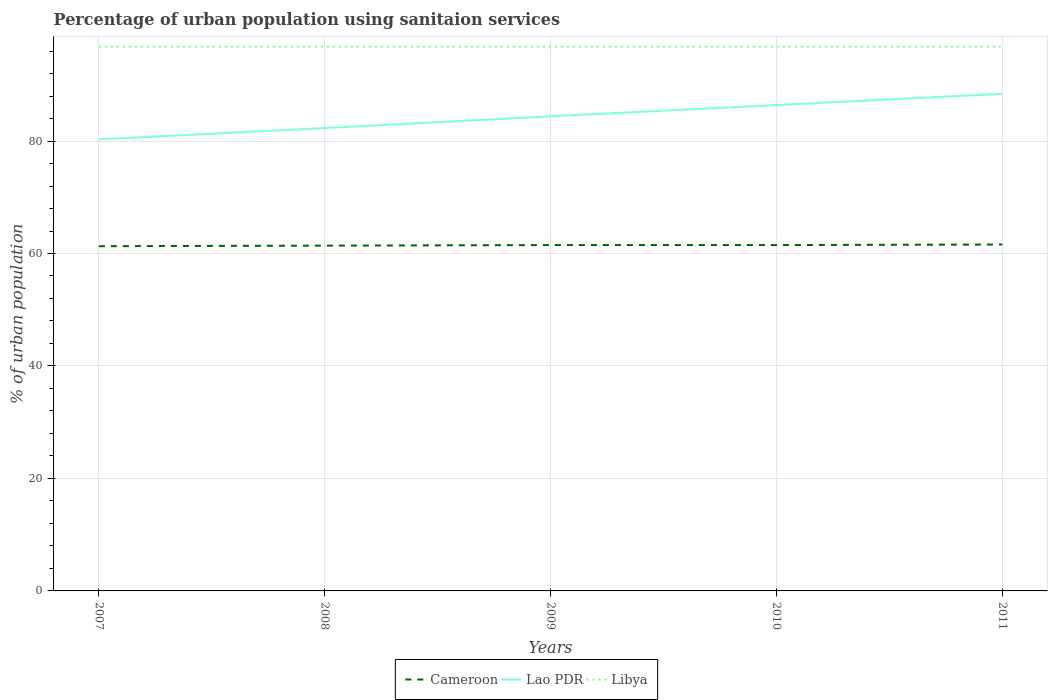Is the number of lines equal to the number of legend labels?
Your response must be concise. Yes. Across all years, what is the maximum percentage of urban population using sanitaion services in Lao PDR?
Your response must be concise. 80.3. In which year was the percentage of urban population using sanitaion services in Lao PDR maximum?
Give a very brief answer. 2007. What is the total percentage of urban population using sanitaion services in Libya in the graph?
Provide a succinct answer. 0. What is the difference between the highest and the second highest percentage of urban population using sanitaion services in Lao PDR?
Your answer should be compact. 8.1. What is the difference between the highest and the lowest percentage of urban population using sanitaion services in Cameroon?
Your response must be concise. 3. Where does the legend appear in the graph?
Provide a short and direct response. Bottom center. What is the title of the graph?
Your response must be concise. Percentage of urban population using sanitaion services. What is the label or title of the X-axis?
Provide a short and direct response. Years. What is the label or title of the Y-axis?
Your response must be concise. % of urban population. What is the % of urban population of Cameroon in 2007?
Offer a terse response. 61.3. What is the % of urban population of Lao PDR in 2007?
Keep it short and to the point. 80.3. What is the % of urban population in Libya in 2007?
Provide a short and direct response. 96.8. What is the % of urban population in Cameroon in 2008?
Give a very brief answer. 61.4. What is the % of urban population in Lao PDR in 2008?
Give a very brief answer. 82.3. What is the % of urban population in Libya in 2008?
Ensure brevity in your answer.  96.8. What is the % of urban population in Cameroon in 2009?
Offer a terse response. 61.5. What is the % of urban population in Lao PDR in 2009?
Provide a short and direct response. 84.4. What is the % of urban population in Libya in 2009?
Your answer should be compact. 96.8. What is the % of urban population in Cameroon in 2010?
Your answer should be very brief. 61.5. What is the % of urban population in Lao PDR in 2010?
Your answer should be very brief. 86.4. What is the % of urban population in Libya in 2010?
Ensure brevity in your answer.  96.8. What is the % of urban population of Cameroon in 2011?
Offer a terse response. 61.6. What is the % of urban population of Lao PDR in 2011?
Your answer should be compact. 88.4. What is the % of urban population in Libya in 2011?
Your answer should be compact. 96.8. Across all years, what is the maximum % of urban population of Cameroon?
Keep it short and to the point. 61.6. Across all years, what is the maximum % of urban population in Lao PDR?
Ensure brevity in your answer.  88.4. Across all years, what is the maximum % of urban population of Libya?
Keep it short and to the point. 96.8. Across all years, what is the minimum % of urban population in Cameroon?
Offer a terse response. 61.3. Across all years, what is the minimum % of urban population in Lao PDR?
Provide a short and direct response. 80.3. Across all years, what is the minimum % of urban population in Libya?
Give a very brief answer. 96.8. What is the total % of urban population of Cameroon in the graph?
Your answer should be very brief. 307.3. What is the total % of urban population in Lao PDR in the graph?
Provide a succinct answer. 421.8. What is the total % of urban population in Libya in the graph?
Offer a very short reply. 484. What is the difference between the % of urban population in Lao PDR in 2007 and that in 2008?
Your response must be concise. -2. What is the difference between the % of urban population of Libya in 2007 and that in 2008?
Offer a very short reply. 0. What is the difference between the % of urban population of Lao PDR in 2007 and that in 2009?
Your response must be concise. -4.1. What is the difference between the % of urban population in Cameroon in 2007 and that in 2010?
Your answer should be compact. -0.2. What is the difference between the % of urban population of Lao PDR in 2007 and that in 2011?
Offer a terse response. -8.1. What is the difference between the % of urban population of Libya in 2007 and that in 2011?
Keep it short and to the point. 0. What is the difference between the % of urban population of Cameroon in 2008 and that in 2010?
Provide a short and direct response. -0.1. What is the difference between the % of urban population in Lao PDR in 2008 and that in 2010?
Your answer should be very brief. -4.1. What is the difference between the % of urban population in Libya in 2008 and that in 2010?
Offer a very short reply. 0. What is the difference between the % of urban population of Libya in 2008 and that in 2011?
Ensure brevity in your answer.  0. What is the difference between the % of urban population of Lao PDR in 2009 and that in 2010?
Ensure brevity in your answer.  -2. What is the difference between the % of urban population of Libya in 2009 and that in 2011?
Your answer should be very brief. 0. What is the difference between the % of urban population in Cameroon in 2010 and that in 2011?
Ensure brevity in your answer.  -0.1. What is the difference between the % of urban population of Lao PDR in 2010 and that in 2011?
Provide a short and direct response. -2. What is the difference between the % of urban population of Libya in 2010 and that in 2011?
Ensure brevity in your answer.  0. What is the difference between the % of urban population in Cameroon in 2007 and the % of urban population in Lao PDR in 2008?
Offer a very short reply. -21. What is the difference between the % of urban population in Cameroon in 2007 and the % of urban population in Libya in 2008?
Give a very brief answer. -35.5. What is the difference between the % of urban population of Lao PDR in 2007 and the % of urban population of Libya in 2008?
Offer a very short reply. -16.5. What is the difference between the % of urban population of Cameroon in 2007 and the % of urban population of Lao PDR in 2009?
Your answer should be compact. -23.1. What is the difference between the % of urban population in Cameroon in 2007 and the % of urban population in Libya in 2009?
Your response must be concise. -35.5. What is the difference between the % of urban population of Lao PDR in 2007 and the % of urban population of Libya in 2009?
Your answer should be very brief. -16.5. What is the difference between the % of urban population in Cameroon in 2007 and the % of urban population in Lao PDR in 2010?
Offer a very short reply. -25.1. What is the difference between the % of urban population in Cameroon in 2007 and the % of urban population in Libya in 2010?
Your answer should be compact. -35.5. What is the difference between the % of urban population in Lao PDR in 2007 and the % of urban population in Libya in 2010?
Your answer should be very brief. -16.5. What is the difference between the % of urban population in Cameroon in 2007 and the % of urban population in Lao PDR in 2011?
Make the answer very short. -27.1. What is the difference between the % of urban population in Cameroon in 2007 and the % of urban population in Libya in 2011?
Make the answer very short. -35.5. What is the difference between the % of urban population in Lao PDR in 2007 and the % of urban population in Libya in 2011?
Offer a very short reply. -16.5. What is the difference between the % of urban population in Cameroon in 2008 and the % of urban population in Lao PDR in 2009?
Ensure brevity in your answer.  -23. What is the difference between the % of urban population of Cameroon in 2008 and the % of urban population of Libya in 2009?
Offer a very short reply. -35.4. What is the difference between the % of urban population of Cameroon in 2008 and the % of urban population of Lao PDR in 2010?
Provide a succinct answer. -25. What is the difference between the % of urban population in Cameroon in 2008 and the % of urban population in Libya in 2010?
Provide a succinct answer. -35.4. What is the difference between the % of urban population in Lao PDR in 2008 and the % of urban population in Libya in 2010?
Your answer should be compact. -14.5. What is the difference between the % of urban population of Cameroon in 2008 and the % of urban population of Libya in 2011?
Make the answer very short. -35.4. What is the difference between the % of urban population in Cameroon in 2009 and the % of urban population in Lao PDR in 2010?
Ensure brevity in your answer.  -24.9. What is the difference between the % of urban population of Cameroon in 2009 and the % of urban population of Libya in 2010?
Ensure brevity in your answer.  -35.3. What is the difference between the % of urban population of Lao PDR in 2009 and the % of urban population of Libya in 2010?
Ensure brevity in your answer.  -12.4. What is the difference between the % of urban population in Cameroon in 2009 and the % of urban population in Lao PDR in 2011?
Your answer should be compact. -26.9. What is the difference between the % of urban population in Cameroon in 2009 and the % of urban population in Libya in 2011?
Your response must be concise. -35.3. What is the difference between the % of urban population of Lao PDR in 2009 and the % of urban population of Libya in 2011?
Your answer should be compact. -12.4. What is the difference between the % of urban population of Cameroon in 2010 and the % of urban population of Lao PDR in 2011?
Keep it short and to the point. -26.9. What is the difference between the % of urban population in Cameroon in 2010 and the % of urban population in Libya in 2011?
Provide a succinct answer. -35.3. What is the average % of urban population in Cameroon per year?
Offer a very short reply. 61.46. What is the average % of urban population of Lao PDR per year?
Provide a short and direct response. 84.36. What is the average % of urban population of Libya per year?
Offer a very short reply. 96.8. In the year 2007, what is the difference between the % of urban population in Cameroon and % of urban population in Lao PDR?
Offer a terse response. -19. In the year 2007, what is the difference between the % of urban population of Cameroon and % of urban population of Libya?
Provide a succinct answer. -35.5. In the year 2007, what is the difference between the % of urban population in Lao PDR and % of urban population in Libya?
Offer a very short reply. -16.5. In the year 2008, what is the difference between the % of urban population of Cameroon and % of urban population of Lao PDR?
Your answer should be compact. -20.9. In the year 2008, what is the difference between the % of urban population in Cameroon and % of urban population in Libya?
Provide a short and direct response. -35.4. In the year 2008, what is the difference between the % of urban population of Lao PDR and % of urban population of Libya?
Give a very brief answer. -14.5. In the year 2009, what is the difference between the % of urban population in Cameroon and % of urban population in Lao PDR?
Give a very brief answer. -22.9. In the year 2009, what is the difference between the % of urban population in Cameroon and % of urban population in Libya?
Provide a short and direct response. -35.3. In the year 2009, what is the difference between the % of urban population in Lao PDR and % of urban population in Libya?
Your answer should be very brief. -12.4. In the year 2010, what is the difference between the % of urban population of Cameroon and % of urban population of Lao PDR?
Your answer should be compact. -24.9. In the year 2010, what is the difference between the % of urban population in Cameroon and % of urban population in Libya?
Provide a succinct answer. -35.3. In the year 2010, what is the difference between the % of urban population in Lao PDR and % of urban population in Libya?
Keep it short and to the point. -10.4. In the year 2011, what is the difference between the % of urban population of Cameroon and % of urban population of Lao PDR?
Provide a short and direct response. -26.8. In the year 2011, what is the difference between the % of urban population of Cameroon and % of urban population of Libya?
Offer a terse response. -35.2. What is the ratio of the % of urban population in Cameroon in 2007 to that in 2008?
Your answer should be compact. 1. What is the ratio of the % of urban population in Lao PDR in 2007 to that in 2008?
Ensure brevity in your answer.  0.98. What is the ratio of the % of urban population of Libya in 2007 to that in 2008?
Give a very brief answer. 1. What is the ratio of the % of urban population in Cameroon in 2007 to that in 2009?
Your answer should be very brief. 1. What is the ratio of the % of urban population in Lao PDR in 2007 to that in 2009?
Your answer should be compact. 0.95. What is the ratio of the % of urban population of Cameroon in 2007 to that in 2010?
Your response must be concise. 1. What is the ratio of the % of urban population of Lao PDR in 2007 to that in 2010?
Offer a very short reply. 0.93. What is the ratio of the % of urban population of Cameroon in 2007 to that in 2011?
Offer a terse response. 1. What is the ratio of the % of urban population in Lao PDR in 2007 to that in 2011?
Give a very brief answer. 0.91. What is the ratio of the % of urban population of Lao PDR in 2008 to that in 2009?
Provide a succinct answer. 0.98. What is the ratio of the % of urban population of Libya in 2008 to that in 2009?
Ensure brevity in your answer.  1. What is the ratio of the % of urban population in Lao PDR in 2008 to that in 2010?
Ensure brevity in your answer.  0.95. What is the ratio of the % of urban population of Libya in 2008 to that in 2011?
Give a very brief answer. 1. What is the ratio of the % of urban population in Lao PDR in 2009 to that in 2010?
Your answer should be compact. 0.98. What is the ratio of the % of urban population in Lao PDR in 2009 to that in 2011?
Offer a very short reply. 0.95. What is the ratio of the % of urban population in Libya in 2009 to that in 2011?
Your response must be concise. 1. What is the ratio of the % of urban population in Cameroon in 2010 to that in 2011?
Keep it short and to the point. 1. What is the ratio of the % of urban population of Lao PDR in 2010 to that in 2011?
Provide a succinct answer. 0.98. What is the ratio of the % of urban population of Libya in 2010 to that in 2011?
Ensure brevity in your answer.  1. What is the difference between the highest and the lowest % of urban population in Lao PDR?
Give a very brief answer. 8.1. 